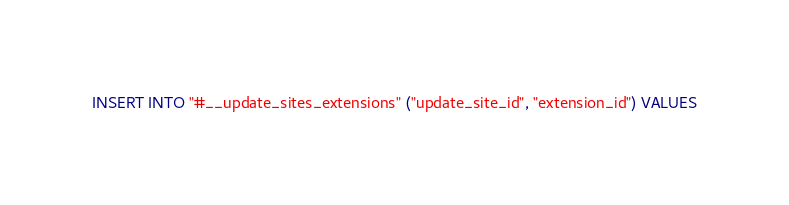Convert code to text. <code><loc_0><loc_0><loc_500><loc_500><_SQL_>INSERT INTO "#__update_sites_extensions" ("update_site_id", "extension_id") VALUES</code> 